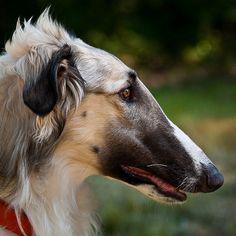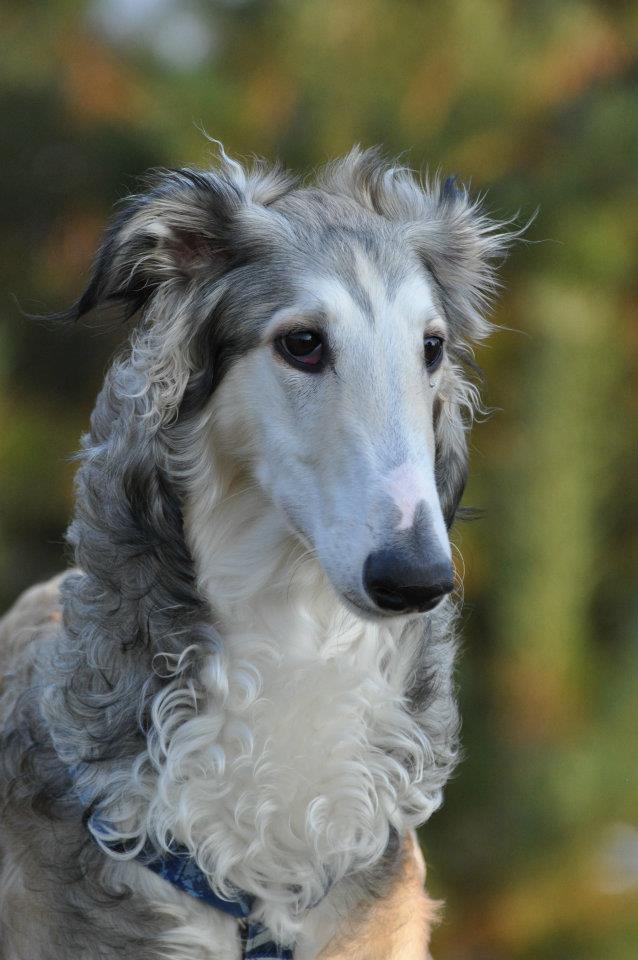The first image is the image on the left, the second image is the image on the right. Analyze the images presented: Is the assertion "In both images only the head of the dog can be seen and not the rest of the dogs body." valid? Answer yes or no. Yes. 